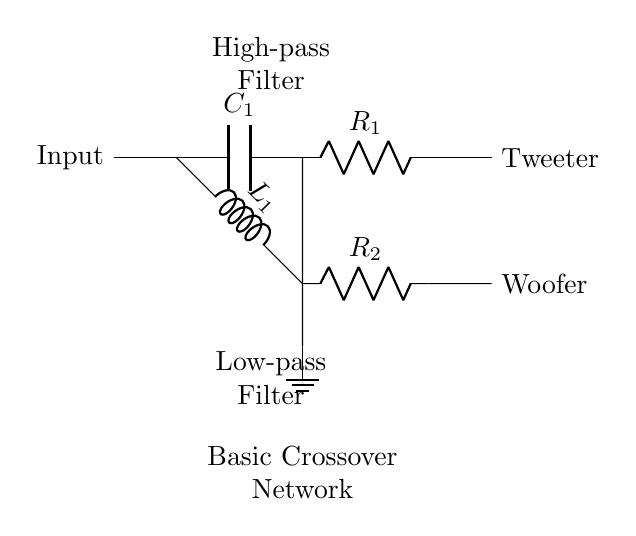What is the first component in the circuit? The first component is a capacitor labeled C1. It is located immediately after the input, used in the high-pass filter section.
Answer: C1 What type of filter is represented in the upper part of the circuit? The upper part of the circuit includes a capacitor followed by a resistor, which creates a high-pass filter that allows high frequencies to pass while attenuating low frequencies.
Answer: High-pass filter How many outputs does the crossover network have? There are two outputs: one for the tweeter and one for the woofer, shown at the right end of the diagram, each connected to different parts of the circuit.
Answer: Two What is the role of the inductor in this circuit? The inductor, labeled L1, is part of the low-pass filter, which allows low frequencies to pass through while blocking higher frequencies from reaching the woofer.
Answer: Low-pass filter What does the ground symbol indicate in this circuit? The ground symbol indicates a common reference point for the circuit, ensuring that all components share the same reference voltage, which is necessary for circuit operation.
Answer: Common reference Which component is used to limit the current to the woofer? The resistor labeled R2 is connected in series with the inductor L1, creating the low-pass filter that limits the current to the woofer based on its frequency management.
Answer: R2 